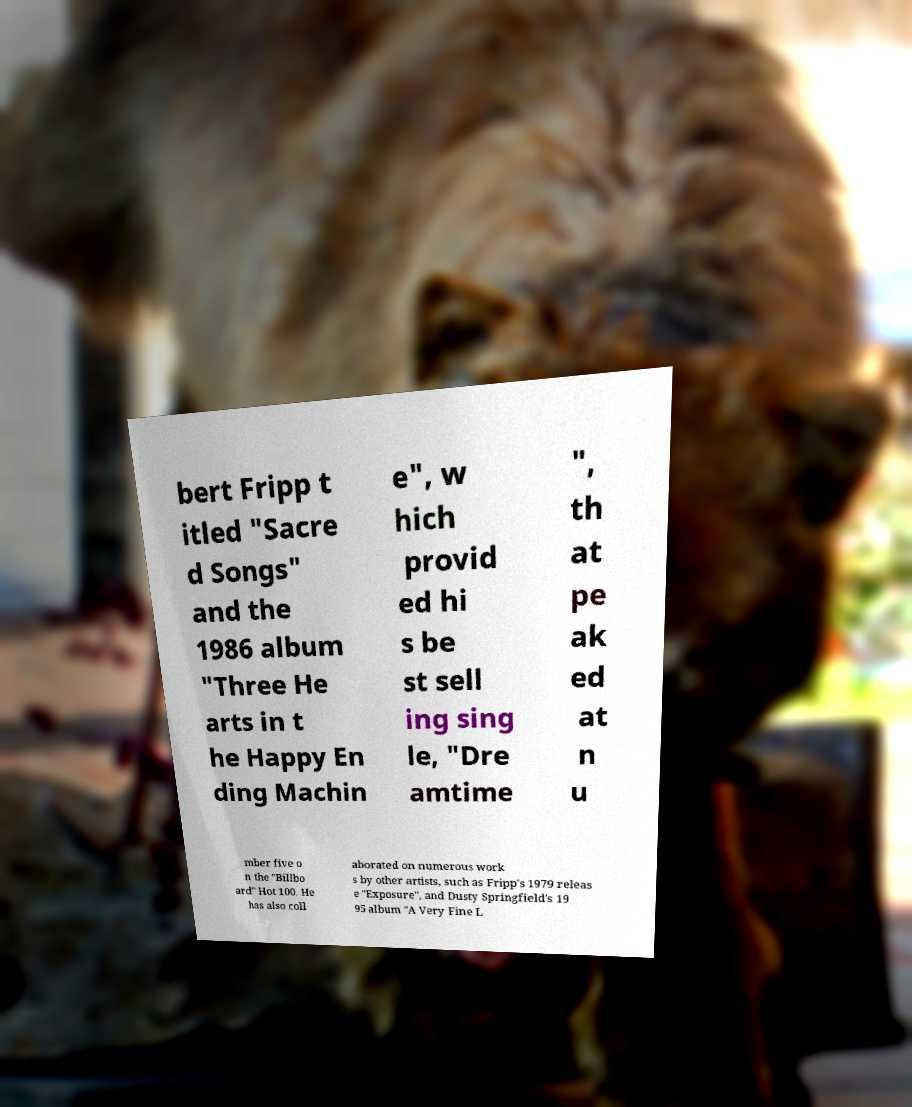Please identify and transcribe the text found in this image. bert Fripp t itled "Sacre d Songs" and the 1986 album "Three He arts in t he Happy En ding Machin e", w hich provid ed hi s be st sell ing sing le, "Dre amtime ", th at pe ak ed at n u mber five o n the "Billbo ard" Hot 100. He has also coll aborated on numerous work s by other artists, such as Fripp's 1979 releas e "Exposure", and Dusty Springfield's 19 95 album "A Very Fine L 